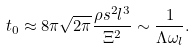<formula> <loc_0><loc_0><loc_500><loc_500>t _ { 0 } \approx 8 \pi \sqrt { 2 \pi } \frac { \rho s ^ { 2 } l ^ { 3 } } { \Xi ^ { 2 } } \sim \frac { 1 } { \Lambda \omega _ { l } } .</formula> 